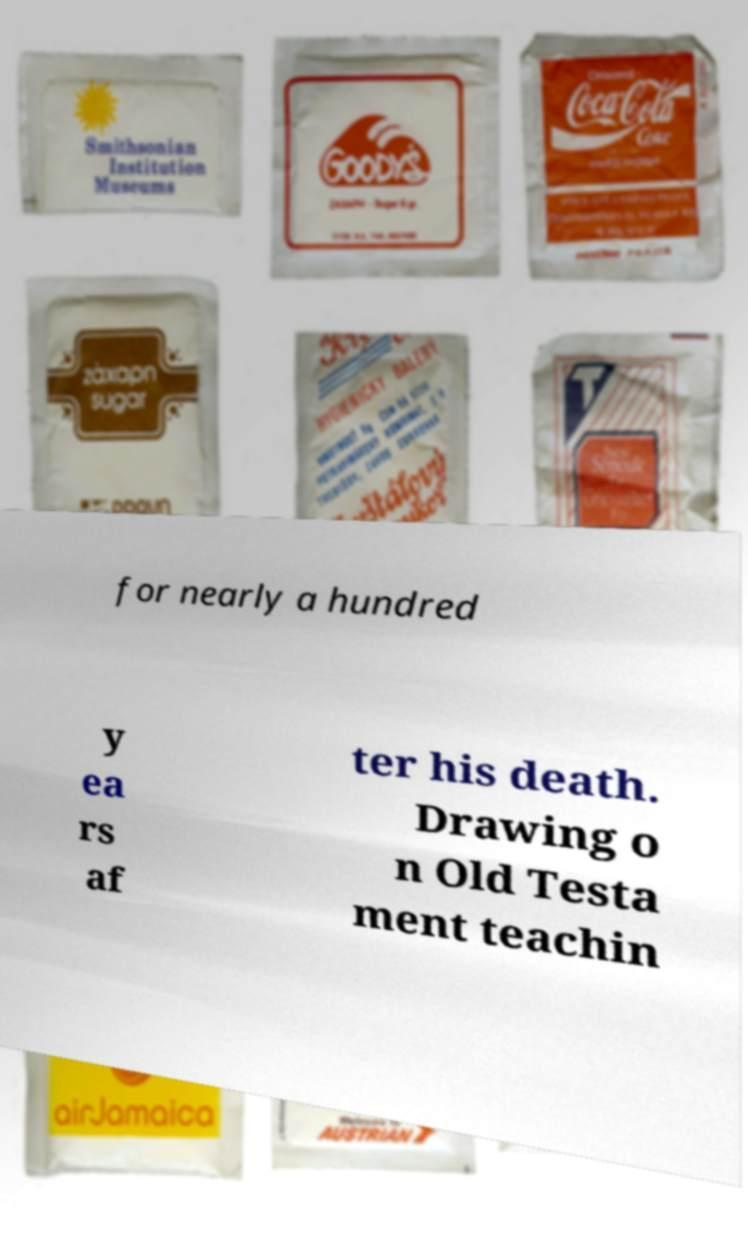What messages or text are displayed in this image? I need them in a readable, typed format. for nearly a hundred y ea rs af ter his death. Drawing o n Old Testa ment teachin 